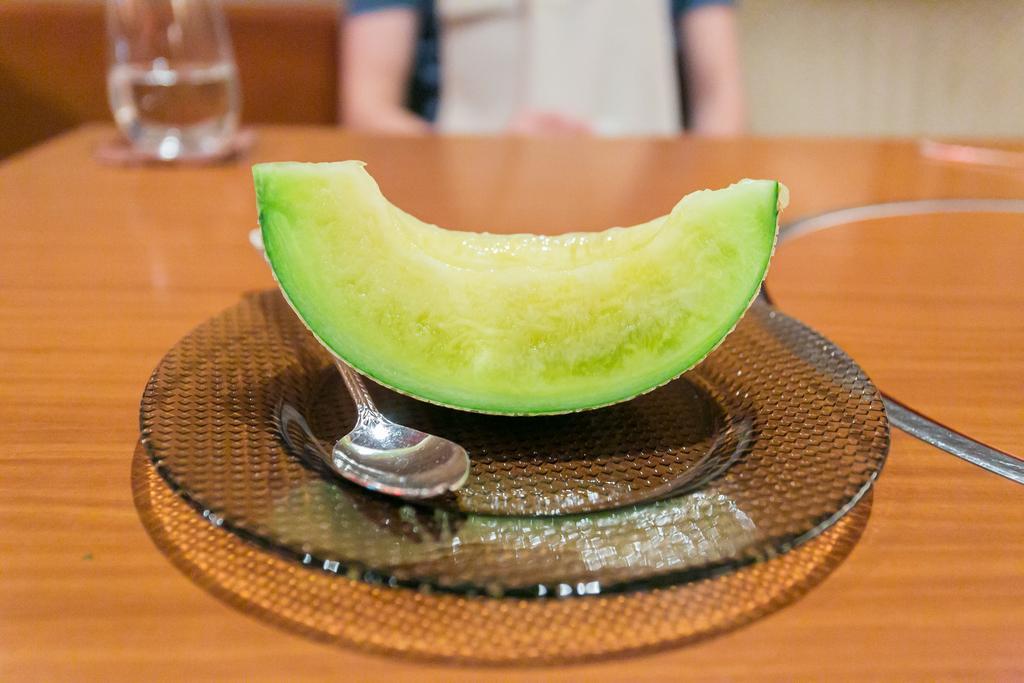Could you give a brief overview of what you see in this image? In this image we can see a piece of honeydew and a spoon in a plate which are placed on the table. We can also see a glass with some water beside it. On the backside we can see a person. 